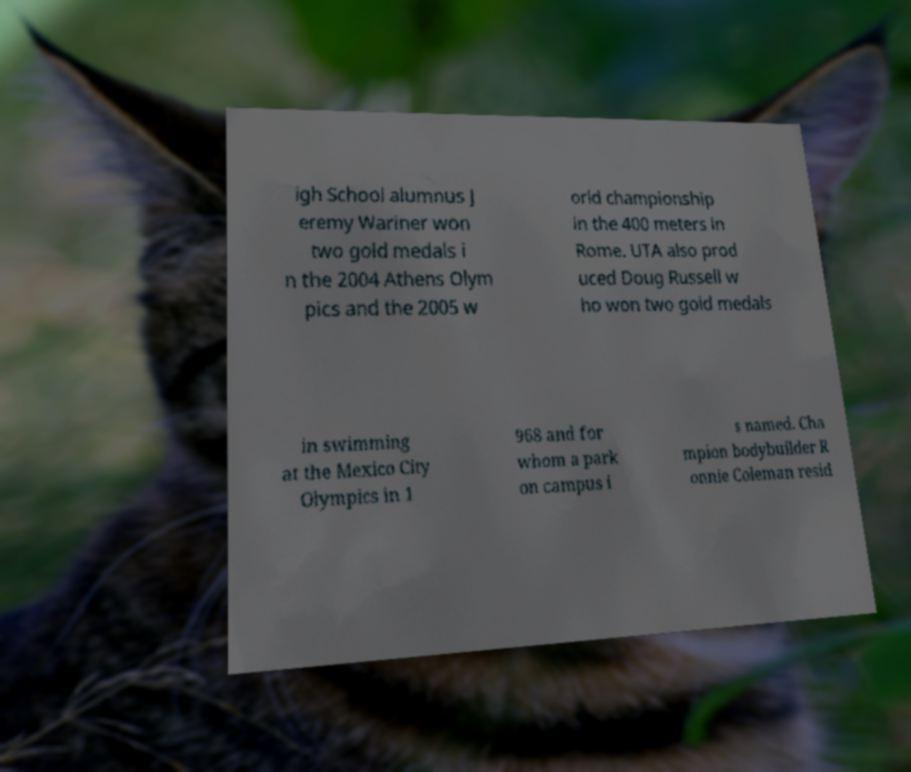Could you extract and type out the text from this image? igh School alumnus J eremy Wariner won two gold medals i n the 2004 Athens Olym pics and the 2005 w orld championship in the 400 meters in Rome. UTA also prod uced Doug Russell w ho won two gold medals in swimming at the Mexico City Olympics in 1 968 and for whom a park on campus i s named. Cha mpion bodybuilder R onnie Coleman resid 